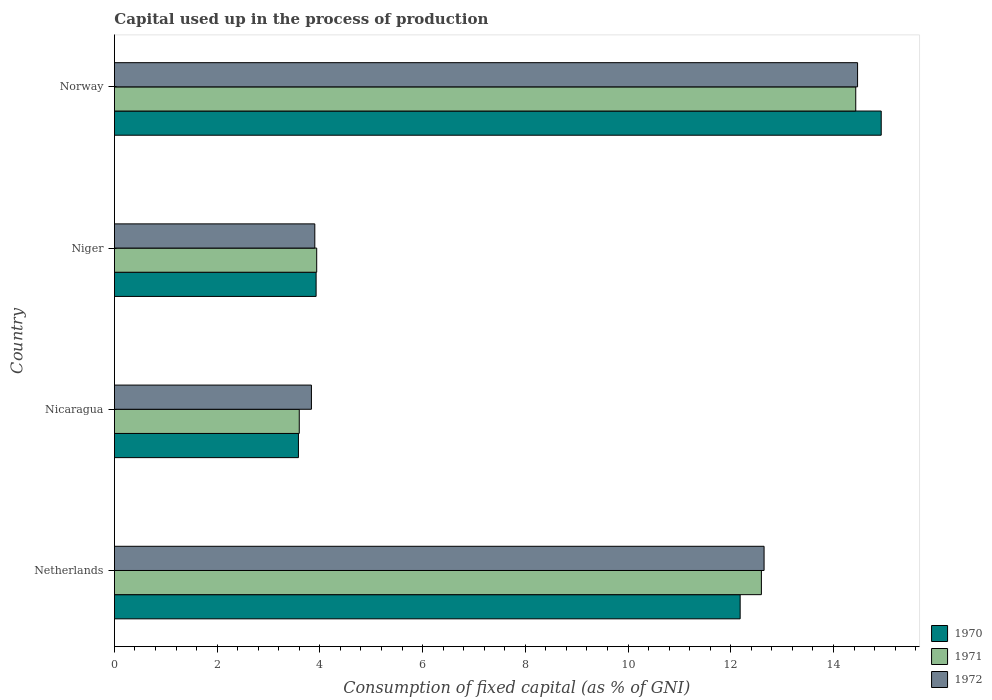How many groups of bars are there?
Your answer should be very brief. 4. Are the number of bars per tick equal to the number of legend labels?
Make the answer very short. Yes. How many bars are there on the 4th tick from the bottom?
Provide a short and direct response. 3. What is the label of the 4th group of bars from the top?
Give a very brief answer. Netherlands. What is the capital used up in the process of production in 1970 in Norway?
Offer a very short reply. 14.93. Across all countries, what is the maximum capital used up in the process of production in 1970?
Provide a succinct answer. 14.93. Across all countries, what is the minimum capital used up in the process of production in 1971?
Make the answer very short. 3.6. In which country was the capital used up in the process of production in 1972 minimum?
Your answer should be compact. Nicaragua. What is the total capital used up in the process of production in 1970 in the graph?
Your answer should be compact. 34.62. What is the difference between the capital used up in the process of production in 1971 in Nicaragua and that in Norway?
Offer a very short reply. -10.84. What is the difference between the capital used up in the process of production in 1971 in Netherlands and the capital used up in the process of production in 1972 in Nicaragua?
Provide a succinct answer. 8.76. What is the average capital used up in the process of production in 1972 per country?
Provide a short and direct response. 8.71. What is the difference between the capital used up in the process of production in 1970 and capital used up in the process of production in 1972 in Nicaragua?
Make the answer very short. -0.25. What is the ratio of the capital used up in the process of production in 1971 in Netherlands to that in Niger?
Your answer should be very brief. 3.2. Is the capital used up in the process of production in 1972 in Netherlands less than that in Niger?
Your answer should be compact. No. Is the difference between the capital used up in the process of production in 1970 in Netherlands and Nicaragua greater than the difference between the capital used up in the process of production in 1972 in Netherlands and Nicaragua?
Keep it short and to the point. No. What is the difference between the highest and the second highest capital used up in the process of production in 1972?
Offer a terse response. 1.82. What is the difference between the highest and the lowest capital used up in the process of production in 1971?
Your response must be concise. 10.84. Is the sum of the capital used up in the process of production in 1972 in Nicaragua and Niger greater than the maximum capital used up in the process of production in 1971 across all countries?
Your response must be concise. No. Is it the case that in every country, the sum of the capital used up in the process of production in 1971 and capital used up in the process of production in 1970 is greater than the capital used up in the process of production in 1972?
Offer a terse response. Yes. How many countries are there in the graph?
Offer a very short reply. 4. Are the values on the major ticks of X-axis written in scientific E-notation?
Offer a terse response. No. Does the graph contain any zero values?
Offer a very short reply. No. How many legend labels are there?
Ensure brevity in your answer.  3. What is the title of the graph?
Your response must be concise. Capital used up in the process of production. Does "1966" appear as one of the legend labels in the graph?
Your answer should be very brief. No. What is the label or title of the X-axis?
Make the answer very short. Consumption of fixed capital (as % of GNI). What is the Consumption of fixed capital (as % of GNI) of 1970 in Netherlands?
Keep it short and to the point. 12.18. What is the Consumption of fixed capital (as % of GNI) in 1971 in Netherlands?
Provide a succinct answer. 12.6. What is the Consumption of fixed capital (as % of GNI) in 1972 in Netherlands?
Your answer should be very brief. 12.65. What is the Consumption of fixed capital (as % of GNI) in 1970 in Nicaragua?
Your answer should be compact. 3.58. What is the Consumption of fixed capital (as % of GNI) in 1971 in Nicaragua?
Offer a terse response. 3.6. What is the Consumption of fixed capital (as % of GNI) of 1972 in Nicaragua?
Your answer should be compact. 3.84. What is the Consumption of fixed capital (as % of GNI) of 1970 in Niger?
Offer a terse response. 3.93. What is the Consumption of fixed capital (as % of GNI) in 1971 in Niger?
Give a very brief answer. 3.94. What is the Consumption of fixed capital (as % of GNI) in 1972 in Niger?
Offer a very short reply. 3.9. What is the Consumption of fixed capital (as % of GNI) in 1970 in Norway?
Make the answer very short. 14.93. What is the Consumption of fixed capital (as % of GNI) of 1971 in Norway?
Offer a terse response. 14.43. What is the Consumption of fixed capital (as % of GNI) of 1972 in Norway?
Your answer should be very brief. 14.47. Across all countries, what is the maximum Consumption of fixed capital (as % of GNI) of 1970?
Give a very brief answer. 14.93. Across all countries, what is the maximum Consumption of fixed capital (as % of GNI) in 1971?
Your answer should be compact. 14.43. Across all countries, what is the maximum Consumption of fixed capital (as % of GNI) in 1972?
Your answer should be compact. 14.47. Across all countries, what is the minimum Consumption of fixed capital (as % of GNI) in 1970?
Keep it short and to the point. 3.58. Across all countries, what is the minimum Consumption of fixed capital (as % of GNI) in 1971?
Offer a terse response. 3.6. Across all countries, what is the minimum Consumption of fixed capital (as % of GNI) in 1972?
Your answer should be compact. 3.84. What is the total Consumption of fixed capital (as % of GNI) of 1970 in the graph?
Provide a succinct answer. 34.62. What is the total Consumption of fixed capital (as % of GNI) in 1971 in the graph?
Provide a short and direct response. 34.57. What is the total Consumption of fixed capital (as % of GNI) of 1972 in the graph?
Offer a very short reply. 34.86. What is the difference between the Consumption of fixed capital (as % of GNI) in 1970 in Netherlands and that in Nicaragua?
Give a very brief answer. 8.6. What is the difference between the Consumption of fixed capital (as % of GNI) in 1971 in Netherlands and that in Nicaragua?
Your response must be concise. 9. What is the difference between the Consumption of fixed capital (as % of GNI) in 1972 in Netherlands and that in Nicaragua?
Offer a very short reply. 8.81. What is the difference between the Consumption of fixed capital (as % of GNI) of 1970 in Netherlands and that in Niger?
Ensure brevity in your answer.  8.26. What is the difference between the Consumption of fixed capital (as % of GNI) in 1971 in Netherlands and that in Niger?
Give a very brief answer. 8.66. What is the difference between the Consumption of fixed capital (as % of GNI) in 1972 in Netherlands and that in Niger?
Your response must be concise. 8.75. What is the difference between the Consumption of fixed capital (as % of GNI) in 1970 in Netherlands and that in Norway?
Give a very brief answer. -2.75. What is the difference between the Consumption of fixed capital (as % of GNI) of 1971 in Netherlands and that in Norway?
Give a very brief answer. -1.84. What is the difference between the Consumption of fixed capital (as % of GNI) in 1972 in Netherlands and that in Norway?
Make the answer very short. -1.82. What is the difference between the Consumption of fixed capital (as % of GNI) in 1970 in Nicaragua and that in Niger?
Offer a terse response. -0.34. What is the difference between the Consumption of fixed capital (as % of GNI) in 1971 in Nicaragua and that in Niger?
Offer a terse response. -0.34. What is the difference between the Consumption of fixed capital (as % of GNI) in 1972 in Nicaragua and that in Niger?
Your answer should be very brief. -0.07. What is the difference between the Consumption of fixed capital (as % of GNI) in 1970 in Nicaragua and that in Norway?
Your answer should be compact. -11.35. What is the difference between the Consumption of fixed capital (as % of GNI) in 1971 in Nicaragua and that in Norway?
Ensure brevity in your answer.  -10.84. What is the difference between the Consumption of fixed capital (as % of GNI) of 1972 in Nicaragua and that in Norway?
Make the answer very short. -10.63. What is the difference between the Consumption of fixed capital (as % of GNI) in 1970 in Niger and that in Norway?
Offer a terse response. -11. What is the difference between the Consumption of fixed capital (as % of GNI) of 1971 in Niger and that in Norway?
Provide a succinct answer. -10.5. What is the difference between the Consumption of fixed capital (as % of GNI) of 1972 in Niger and that in Norway?
Your response must be concise. -10.57. What is the difference between the Consumption of fixed capital (as % of GNI) of 1970 in Netherlands and the Consumption of fixed capital (as % of GNI) of 1971 in Nicaragua?
Your answer should be compact. 8.58. What is the difference between the Consumption of fixed capital (as % of GNI) in 1970 in Netherlands and the Consumption of fixed capital (as % of GNI) in 1972 in Nicaragua?
Give a very brief answer. 8.35. What is the difference between the Consumption of fixed capital (as % of GNI) of 1971 in Netherlands and the Consumption of fixed capital (as % of GNI) of 1972 in Nicaragua?
Offer a terse response. 8.76. What is the difference between the Consumption of fixed capital (as % of GNI) of 1970 in Netherlands and the Consumption of fixed capital (as % of GNI) of 1971 in Niger?
Keep it short and to the point. 8.25. What is the difference between the Consumption of fixed capital (as % of GNI) of 1970 in Netherlands and the Consumption of fixed capital (as % of GNI) of 1972 in Niger?
Keep it short and to the point. 8.28. What is the difference between the Consumption of fixed capital (as % of GNI) of 1971 in Netherlands and the Consumption of fixed capital (as % of GNI) of 1972 in Niger?
Offer a very short reply. 8.7. What is the difference between the Consumption of fixed capital (as % of GNI) of 1970 in Netherlands and the Consumption of fixed capital (as % of GNI) of 1971 in Norway?
Your response must be concise. -2.25. What is the difference between the Consumption of fixed capital (as % of GNI) of 1970 in Netherlands and the Consumption of fixed capital (as % of GNI) of 1972 in Norway?
Give a very brief answer. -2.29. What is the difference between the Consumption of fixed capital (as % of GNI) of 1971 in Netherlands and the Consumption of fixed capital (as % of GNI) of 1972 in Norway?
Your answer should be very brief. -1.87. What is the difference between the Consumption of fixed capital (as % of GNI) in 1970 in Nicaragua and the Consumption of fixed capital (as % of GNI) in 1971 in Niger?
Your response must be concise. -0.36. What is the difference between the Consumption of fixed capital (as % of GNI) of 1970 in Nicaragua and the Consumption of fixed capital (as % of GNI) of 1972 in Niger?
Your answer should be very brief. -0.32. What is the difference between the Consumption of fixed capital (as % of GNI) of 1971 in Nicaragua and the Consumption of fixed capital (as % of GNI) of 1972 in Niger?
Your answer should be very brief. -0.3. What is the difference between the Consumption of fixed capital (as % of GNI) in 1970 in Nicaragua and the Consumption of fixed capital (as % of GNI) in 1971 in Norway?
Give a very brief answer. -10.85. What is the difference between the Consumption of fixed capital (as % of GNI) in 1970 in Nicaragua and the Consumption of fixed capital (as % of GNI) in 1972 in Norway?
Give a very brief answer. -10.89. What is the difference between the Consumption of fixed capital (as % of GNI) in 1971 in Nicaragua and the Consumption of fixed capital (as % of GNI) in 1972 in Norway?
Your response must be concise. -10.87. What is the difference between the Consumption of fixed capital (as % of GNI) in 1970 in Niger and the Consumption of fixed capital (as % of GNI) in 1971 in Norway?
Your response must be concise. -10.51. What is the difference between the Consumption of fixed capital (as % of GNI) of 1970 in Niger and the Consumption of fixed capital (as % of GNI) of 1972 in Norway?
Offer a terse response. -10.54. What is the difference between the Consumption of fixed capital (as % of GNI) in 1971 in Niger and the Consumption of fixed capital (as % of GNI) in 1972 in Norway?
Your response must be concise. -10.53. What is the average Consumption of fixed capital (as % of GNI) in 1970 per country?
Your response must be concise. 8.66. What is the average Consumption of fixed capital (as % of GNI) in 1971 per country?
Your answer should be compact. 8.64. What is the average Consumption of fixed capital (as % of GNI) in 1972 per country?
Offer a very short reply. 8.71. What is the difference between the Consumption of fixed capital (as % of GNI) in 1970 and Consumption of fixed capital (as % of GNI) in 1971 in Netherlands?
Give a very brief answer. -0.41. What is the difference between the Consumption of fixed capital (as % of GNI) in 1970 and Consumption of fixed capital (as % of GNI) in 1972 in Netherlands?
Provide a succinct answer. -0.47. What is the difference between the Consumption of fixed capital (as % of GNI) of 1971 and Consumption of fixed capital (as % of GNI) of 1972 in Netherlands?
Provide a short and direct response. -0.05. What is the difference between the Consumption of fixed capital (as % of GNI) in 1970 and Consumption of fixed capital (as % of GNI) in 1971 in Nicaragua?
Your answer should be compact. -0.02. What is the difference between the Consumption of fixed capital (as % of GNI) of 1970 and Consumption of fixed capital (as % of GNI) of 1972 in Nicaragua?
Your answer should be very brief. -0.25. What is the difference between the Consumption of fixed capital (as % of GNI) of 1971 and Consumption of fixed capital (as % of GNI) of 1972 in Nicaragua?
Ensure brevity in your answer.  -0.24. What is the difference between the Consumption of fixed capital (as % of GNI) of 1970 and Consumption of fixed capital (as % of GNI) of 1971 in Niger?
Make the answer very short. -0.01. What is the difference between the Consumption of fixed capital (as % of GNI) in 1970 and Consumption of fixed capital (as % of GNI) in 1972 in Niger?
Your answer should be very brief. 0.03. What is the difference between the Consumption of fixed capital (as % of GNI) in 1971 and Consumption of fixed capital (as % of GNI) in 1972 in Niger?
Provide a short and direct response. 0.04. What is the difference between the Consumption of fixed capital (as % of GNI) of 1970 and Consumption of fixed capital (as % of GNI) of 1971 in Norway?
Provide a short and direct response. 0.5. What is the difference between the Consumption of fixed capital (as % of GNI) of 1970 and Consumption of fixed capital (as % of GNI) of 1972 in Norway?
Your answer should be compact. 0.46. What is the difference between the Consumption of fixed capital (as % of GNI) of 1971 and Consumption of fixed capital (as % of GNI) of 1972 in Norway?
Your answer should be compact. -0.04. What is the ratio of the Consumption of fixed capital (as % of GNI) of 1970 in Netherlands to that in Nicaragua?
Make the answer very short. 3.4. What is the ratio of the Consumption of fixed capital (as % of GNI) in 1971 in Netherlands to that in Nicaragua?
Provide a succinct answer. 3.5. What is the ratio of the Consumption of fixed capital (as % of GNI) in 1972 in Netherlands to that in Nicaragua?
Your answer should be compact. 3.3. What is the ratio of the Consumption of fixed capital (as % of GNI) in 1970 in Netherlands to that in Niger?
Keep it short and to the point. 3.1. What is the ratio of the Consumption of fixed capital (as % of GNI) of 1971 in Netherlands to that in Niger?
Make the answer very short. 3.2. What is the ratio of the Consumption of fixed capital (as % of GNI) in 1972 in Netherlands to that in Niger?
Provide a succinct answer. 3.24. What is the ratio of the Consumption of fixed capital (as % of GNI) in 1970 in Netherlands to that in Norway?
Your answer should be compact. 0.82. What is the ratio of the Consumption of fixed capital (as % of GNI) of 1971 in Netherlands to that in Norway?
Your response must be concise. 0.87. What is the ratio of the Consumption of fixed capital (as % of GNI) of 1972 in Netherlands to that in Norway?
Your answer should be compact. 0.87. What is the ratio of the Consumption of fixed capital (as % of GNI) in 1970 in Nicaragua to that in Niger?
Make the answer very short. 0.91. What is the ratio of the Consumption of fixed capital (as % of GNI) in 1971 in Nicaragua to that in Niger?
Offer a terse response. 0.91. What is the ratio of the Consumption of fixed capital (as % of GNI) in 1972 in Nicaragua to that in Niger?
Your answer should be compact. 0.98. What is the ratio of the Consumption of fixed capital (as % of GNI) of 1970 in Nicaragua to that in Norway?
Ensure brevity in your answer.  0.24. What is the ratio of the Consumption of fixed capital (as % of GNI) of 1971 in Nicaragua to that in Norway?
Offer a terse response. 0.25. What is the ratio of the Consumption of fixed capital (as % of GNI) in 1972 in Nicaragua to that in Norway?
Keep it short and to the point. 0.27. What is the ratio of the Consumption of fixed capital (as % of GNI) in 1970 in Niger to that in Norway?
Offer a very short reply. 0.26. What is the ratio of the Consumption of fixed capital (as % of GNI) in 1971 in Niger to that in Norway?
Keep it short and to the point. 0.27. What is the ratio of the Consumption of fixed capital (as % of GNI) of 1972 in Niger to that in Norway?
Make the answer very short. 0.27. What is the difference between the highest and the second highest Consumption of fixed capital (as % of GNI) of 1970?
Keep it short and to the point. 2.75. What is the difference between the highest and the second highest Consumption of fixed capital (as % of GNI) in 1971?
Provide a succinct answer. 1.84. What is the difference between the highest and the second highest Consumption of fixed capital (as % of GNI) of 1972?
Ensure brevity in your answer.  1.82. What is the difference between the highest and the lowest Consumption of fixed capital (as % of GNI) of 1970?
Ensure brevity in your answer.  11.35. What is the difference between the highest and the lowest Consumption of fixed capital (as % of GNI) in 1971?
Offer a very short reply. 10.84. What is the difference between the highest and the lowest Consumption of fixed capital (as % of GNI) of 1972?
Make the answer very short. 10.63. 